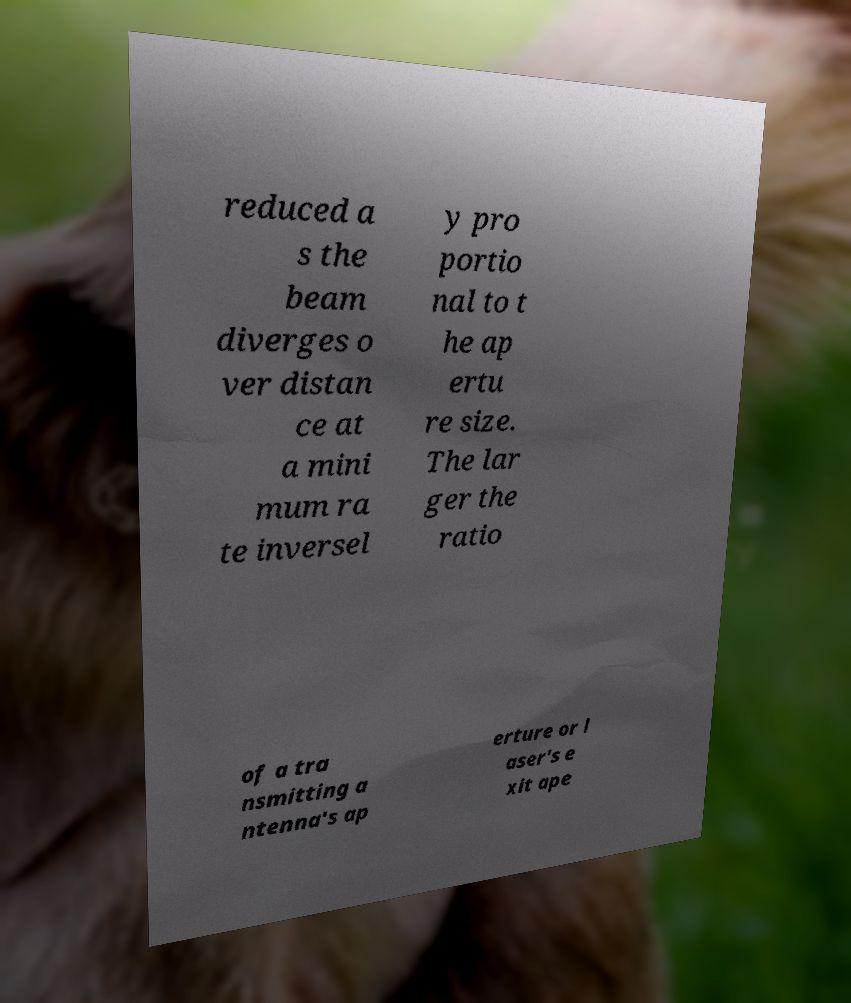Can you read and provide the text displayed in the image?This photo seems to have some interesting text. Can you extract and type it out for me? reduced a s the beam diverges o ver distan ce at a mini mum ra te inversel y pro portio nal to t he ap ertu re size. The lar ger the ratio of a tra nsmitting a ntenna's ap erture or l aser's e xit ape 